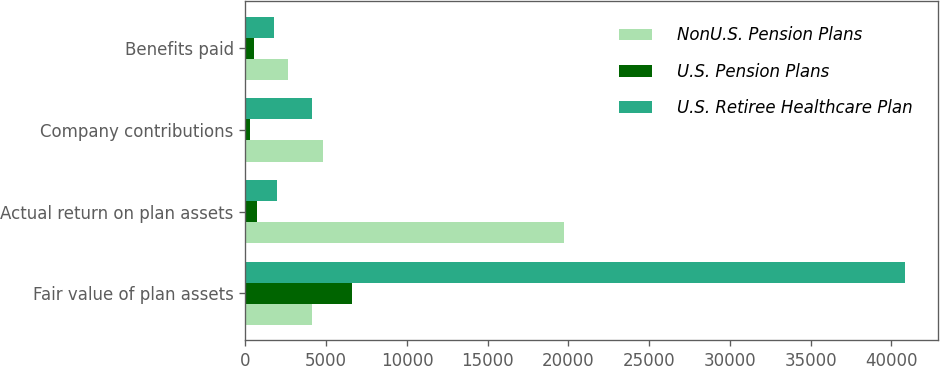Convert chart. <chart><loc_0><loc_0><loc_500><loc_500><stacked_bar_chart><ecel><fcel>Fair value of plan assets<fcel>Actual return on plan assets<fcel>Company contributions<fcel>Benefits paid<nl><fcel>NonU.S. Pension Plans<fcel>4104<fcel>19755<fcel>4820<fcel>2631<nl><fcel>U.S. Pension Plans<fcel>6616<fcel>693<fcel>290<fcel>542<nl><fcel>U.S. Retiree Healthcare Plan<fcel>40820<fcel>1948<fcel>4104<fcel>1743<nl></chart> 